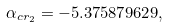Convert formula to latex. <formula><loc_0><loc_0><loc_500><loc_500>\alpha _ { c r _ { 2 } } = - 5 . 3 7 5 8 7 9 6 2 9 ,</formula> 